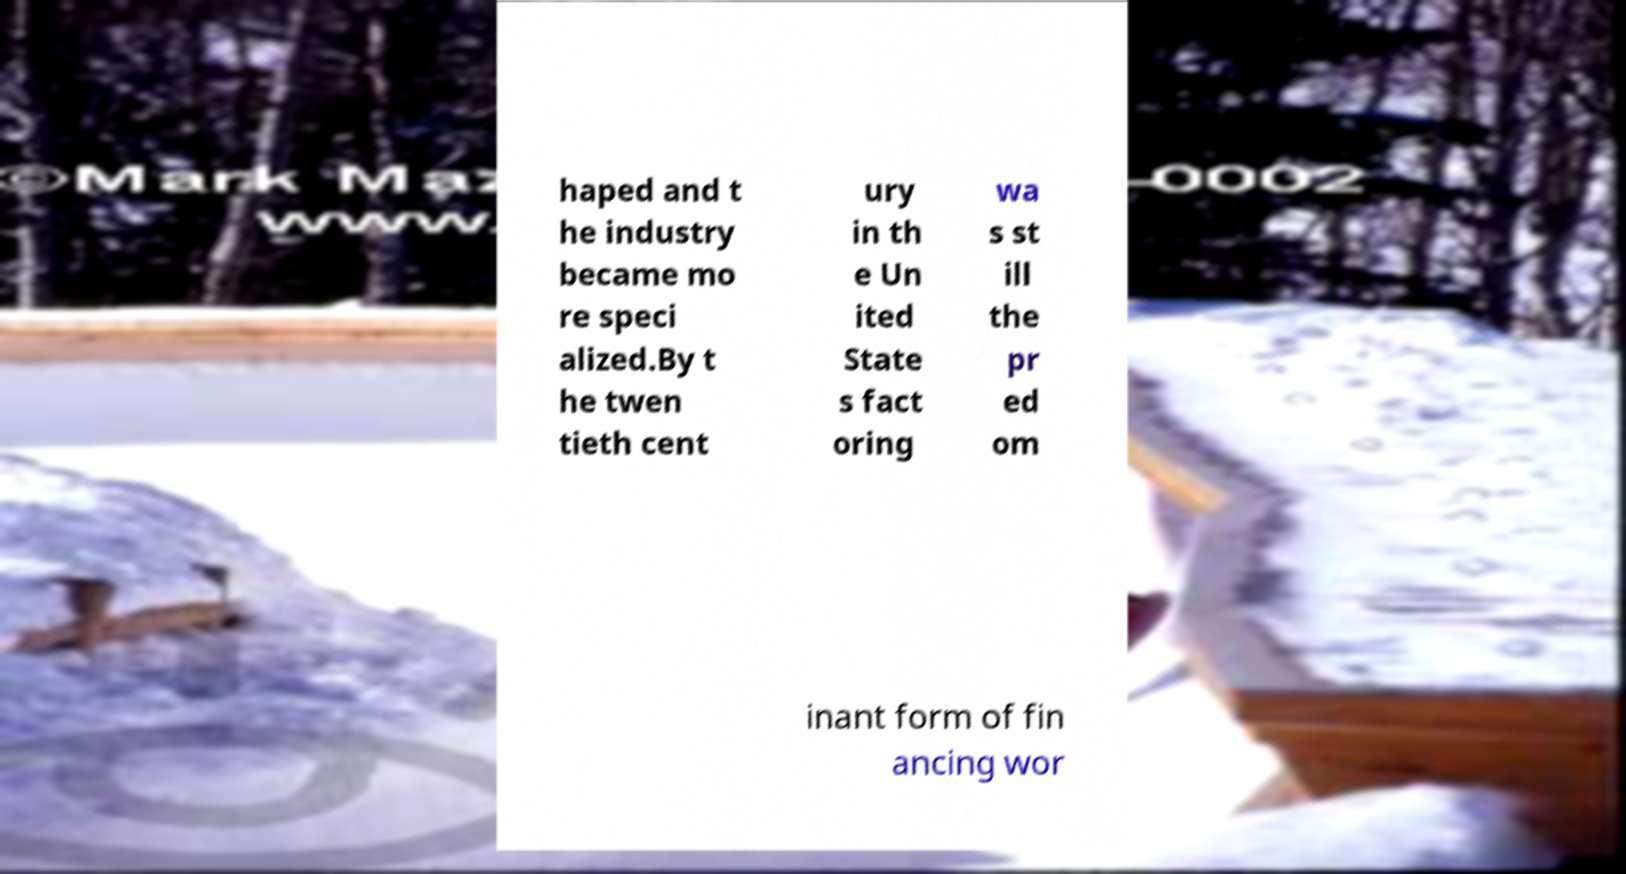Please identify and transcribe the text found in this image. haped and t he industry became mo re speci alized.By t he twen tieth cent ury in th e Un ited State s fact oring wa s st ill the pr ed om inant form of fin ancing wor 